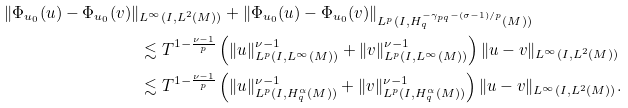Convert formula to latex. <formula><loc_0><loc_0><loc_500><loc_500>\| \Phi _ { u _ { 0 } } ( u ) - \Phi _ { u _ { 0 } } ( v ) \| & _ { L ^ { \infty } ( I , L ^ { 2 } ( M ) ) } + \| \Phi _ { u _ { 0 } } ( u ) - \Phi _ { u _ { 0 } } ( v ) \| _ { L ^ { p } ( I , H ^ { - \gamma _ { p q } - ( \sigma - 1 ) / p } _ { q } ( M ) ) } \\ & \lesssim T ^ { 1 - \frac { \nu - 1 } { p } } \left ( \| u \| ^ { \nu - 1 } _ { L ^ { p } ( I , L ^ { \infty } ( M ) ) } + \| v \| ^ { \nu - 1 } _ { L ^ { p } ( I , L ^ { \infty } ( M ) ) } \right ) \| u - v \| _ { L ^ { \infty } ( I , L ^ { 2 } ( M ) ) } \\ & \lesssim T ^ { 1 - \frac { \nu - 1 } { p } } \left ( \| u \| ^ { \nu - 1 } _ { L ^ { p } ( I , H ^ { \alpha } _ { q } ( M ) ) } + \| v \| ^ { \nu - 1 } _ { L ^ { p } ( I , H ^ { \alpha } _ { q } ( M ) ) } \right ) \| u - v \| _ { L ^ { \infty } ( I , L ^ { 2 } ( M ) ) } .</formula> 